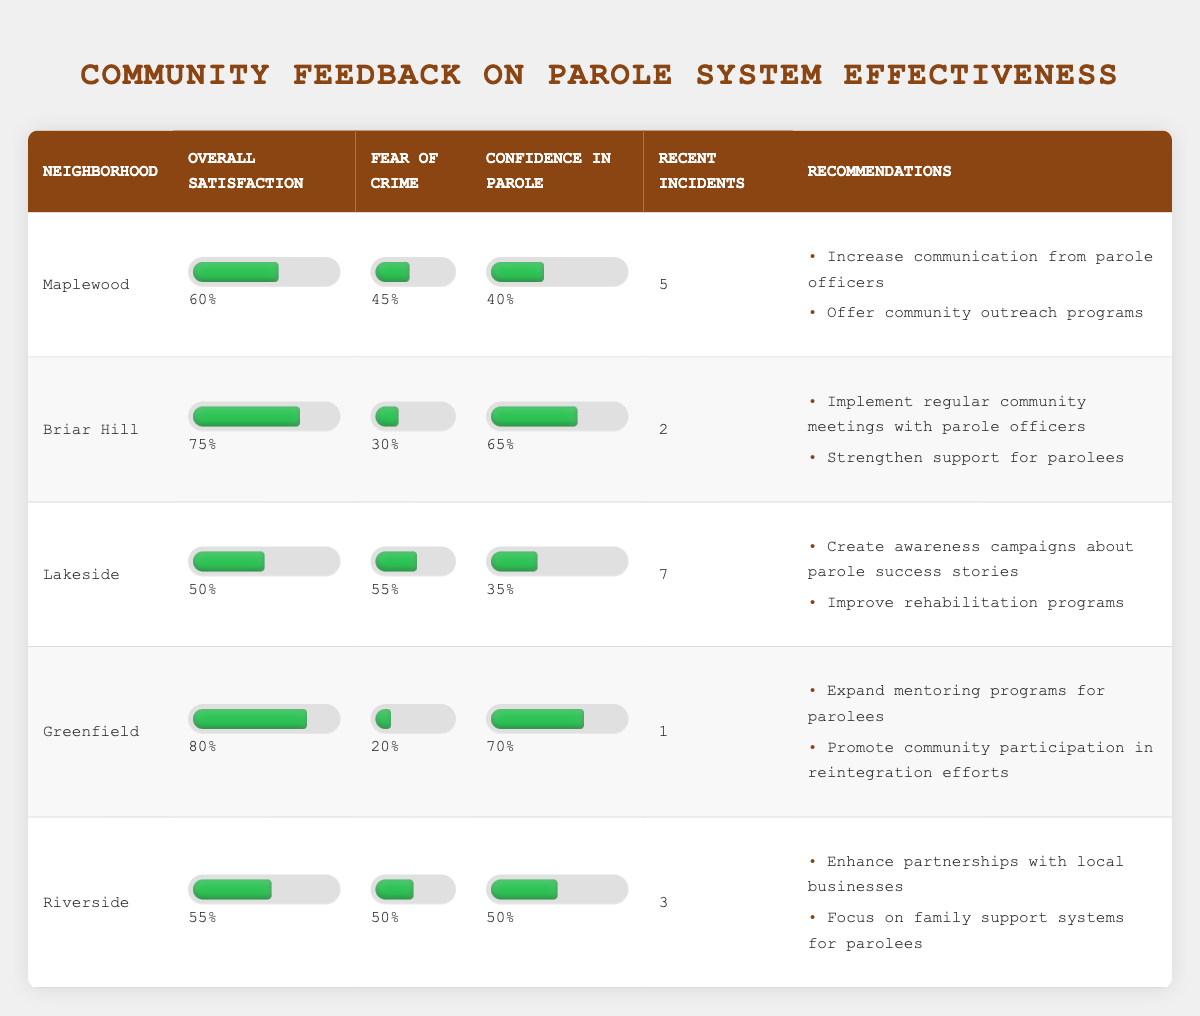What is the overall satisfaction percentage for the Briar Hill neighborhood? From the table, looking at the row for Briar Hill, the Overall Satisfaction is listed as 75%.
Answer: 75% Which neighborhood has the highest fear of crime? By comparing the Fear of Crime values, Lakeside has the highest at 55%.
Answer: Lakeside What is the total number of recent incidents reported in the table? The recent incidents for each neighborhood are: 5 (Maplewood), 2 (Briar Hill), 7 (Lakeside), 1 (Greenfield), and 3 (Riverside). Adding these gives: 5 + 2 + 7 + 1 + 3 = 18.
Answer: 18 Does Greenfield have a higher confidence in parole than Maplewood? Greenfield's Confidence in Parole is at 70%, while Maplewood's is at 40%. Since 70% is greater than 40%, the answer is yes.
Answer: Yes What is the average overall satisfaction among the neighborhoods? The Overall Satisfaction values are 60 (Maplewood), 75 (Briar Hill), 50 (Lakeside), 80 (Greenfield), and 55 (Riverside). The average is calculated by summing these values: 60 + 75 + 50 + 80 + 55 = 320, then dividing by 5 gives 320 / 5 = 64.
Answer: 64 Which neighborhood has the lowest confidence in parole, and what is that percentage? By looking at the Confidence in Parole percentages, Lakeside has the lowest at 35%.
Answer: Lakeside, 35% If Riverside's fear of crime were reduced by 10%, what would be its new fear of crime percentage? Riverside currently has a Fear of Crime of 50%. If reduced by 10%, the new percentage would be 50 - 10 = 40%.
Answer: 40% What recommendations were suggested for the Lakeside neighborhood? The recommendations listed for Lakeside are: "Create awareness campaigns about parole success stories" and "Improve rehabilitation programs."
Answer: Awareness campaigns and improve rehabilitation programs Is there any neighborhood with a 100% confidence in parole? Reviewing the table, the highest Confidence in Parole percentage is 70% (Greenfield). Therefore, there are no neighborhoods with 100% confidence.
Answer: No 